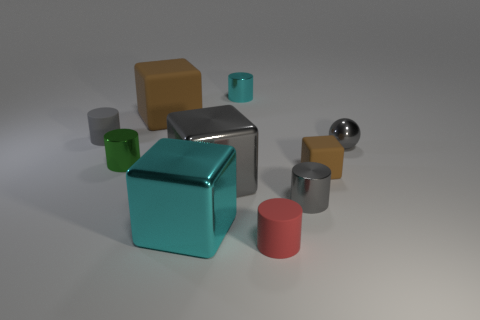Subtract all tiny green shiny cylinders. How many cylinders are left? 4 Subtract all cyan cylinders. How many cylinders are left? 4 Subtract 1 cubes. How many cubes are left? 3 Subtract all purple cubes. Subtract all green cylinders. How many cubes are left? 4 Subtract all spheres. How many objects are left? 9 Add 9 large red matte things. How many large red matte things exist? 9 Subtract 1 brown cubes. How many objects are left? 9 Subtract all small gray cylinders. Subtract all big brown blocks. How many objects are left? 7 Add 4 metallic cylinders. How many metallic cylinders are left? 7 